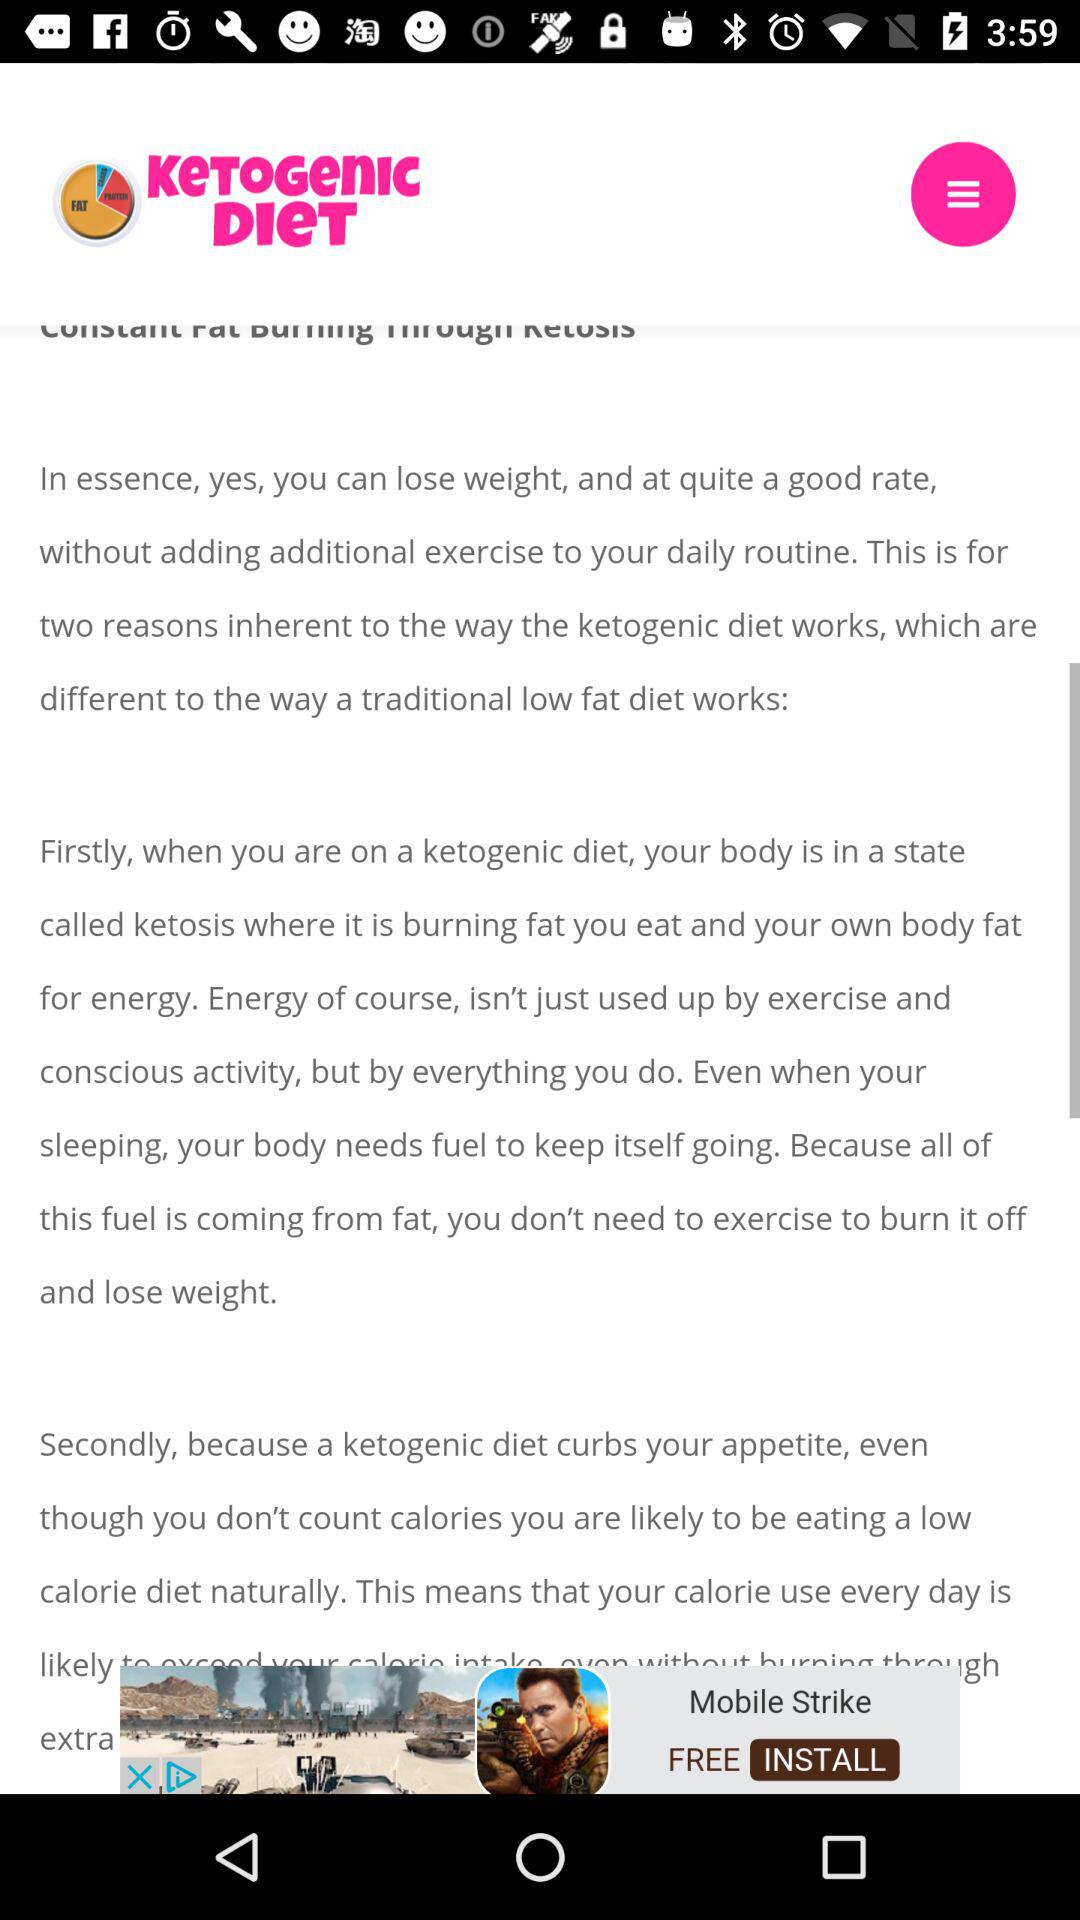What is the name of the application? The name of the application is "KeTOGenIc DIeT". 